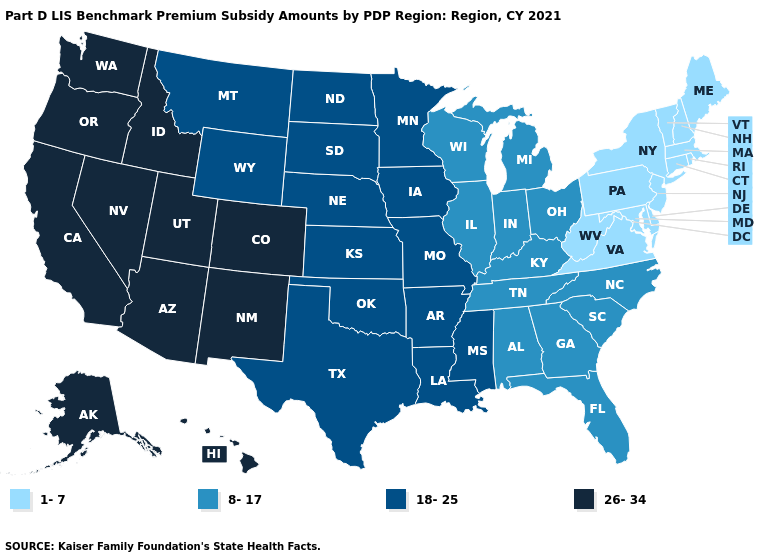Does the first symbol in the legend represent the smallest category?
Give a very brief answer. Yes. Name the states that have a value in the range 26-34?
Quick response, please. Alaska, Arizona, California, Colorado, Hawaii, Idaho, Nevada, New Mexico, Oregon, Utah, Washington. What is the value of Idaho?
Answer briefly. 26-34. What is the value of Delaware?
Keep it brief. 1-7. Name the states that have a value in the range 1-7?
Concise answer only. Connecticut, Delaware, Maine, Maryland, Massachusetts, New Hampshire, New Jersey, New York, Pennsylvania, Rhode Island, Vermont, Virginia, West Virginia. Name the states that have a value in the range 26-34?
Answer briefly. Alaska, Arizona, California, Colorado, Hawaii, Idaho, Nevada, New Mexico, Oregon, Utah, Washington. Which states have the lowest value in the USA?
Answer briefly. Connecticut, Delaware, Maine, Maryland, Massachusetts, New Hampshire, New Jersey, New York, Pennsylvania, Rhode Island, Vermont, Virginia, West Virginia. What is the lowest value in the USA?
Be succinct. 1-7. Name the states that have a value in the range 8-17?
Quick response, please. Alabama, Florida, Georgia, Illinois, Indiana, Kentucky, Michigan, North Carolina, Ohio, South Carolina, Tennessee, Wisconsin. Name the states that have a value in the range 8-17?
Give a very brief answer. Alabama, Florida, Georgia, Illinois, Indiana, Kentucky, Michigan, North Carolina, Ohio, South Carolina, Tennessee, Wisconsin. What is the value of Georgia?
Be succinct. 8-17. What is the value of Iowa?
Be succinct. 18-25. What is the highest value in states that border Wyoming?
Keep it brief. 26-34. What is the value of Rhode Island?
Give a very brief answer. 1-7. Does Texas have the highest value in the USA?
Answer briefly. No. 